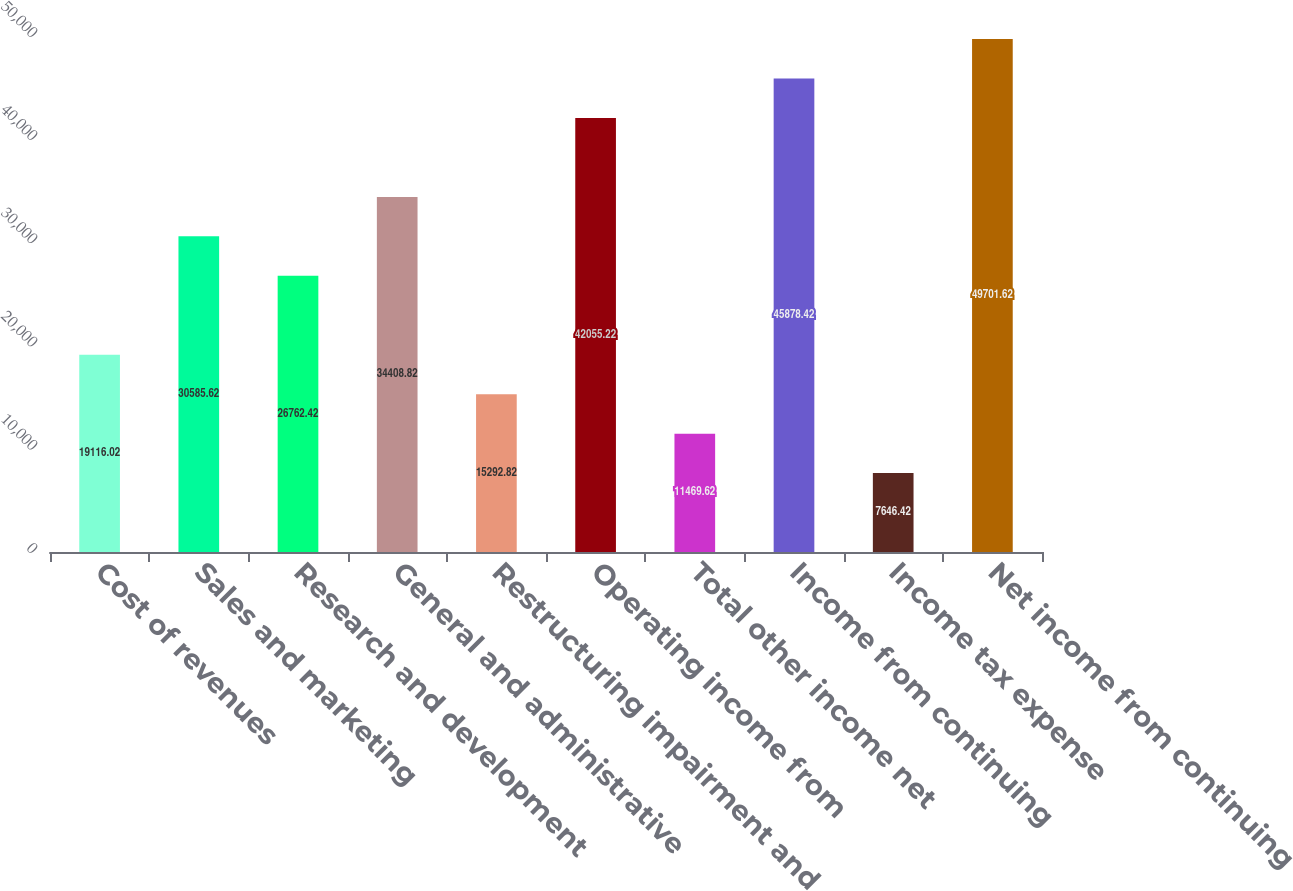Convert chart. <chart><loc_0><loc_0><loc_500><loc_500><bar_chart><fcel>Cost of revenues<fcel>Sales and marketing<fcel>Research and development<fcel>General and administrative<fcel>Restructuring impairment and<fcel>Operating income from<fcel>Total other income net<fcel>Income from continuing<fcel>Income tax expense<fcel>Net income from continuing<nl><fcel>19116<fcel>30585.6<fcel>26762.4<fcel>34408.8<fcel>15292.8<fcel>42055.2<fcel>11469.6<fcel>45878.4<fcel>7646.42<fcel>49701.6<nl></chart> 